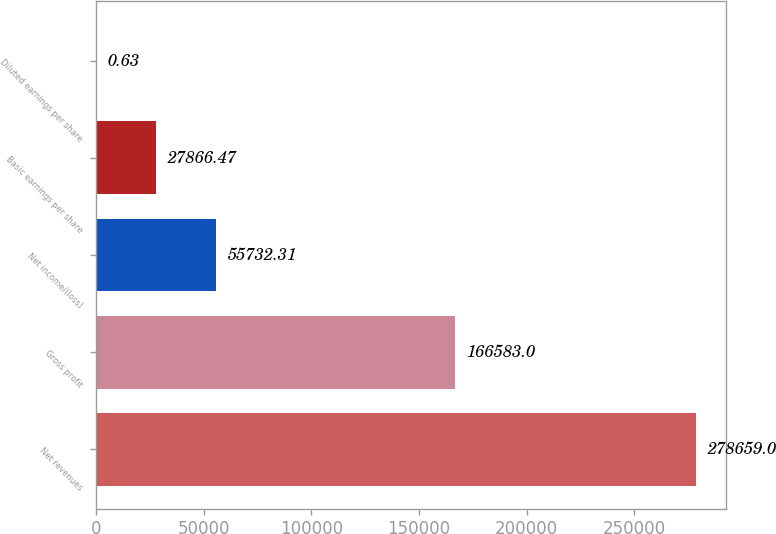<chart> <loc_0><loc_0><loc_500><loc_500><bar_chart><fcel>Net revenues<fcel>Gross profit<fcel>Net income/(loss)<fcel>Basic earnings per share<fcel>Diluted earnings per share<nl><fcel>278659<fcel>166583<fcel>55732.3<fcel>27866.5<fcel>0.63<nl></chart> 